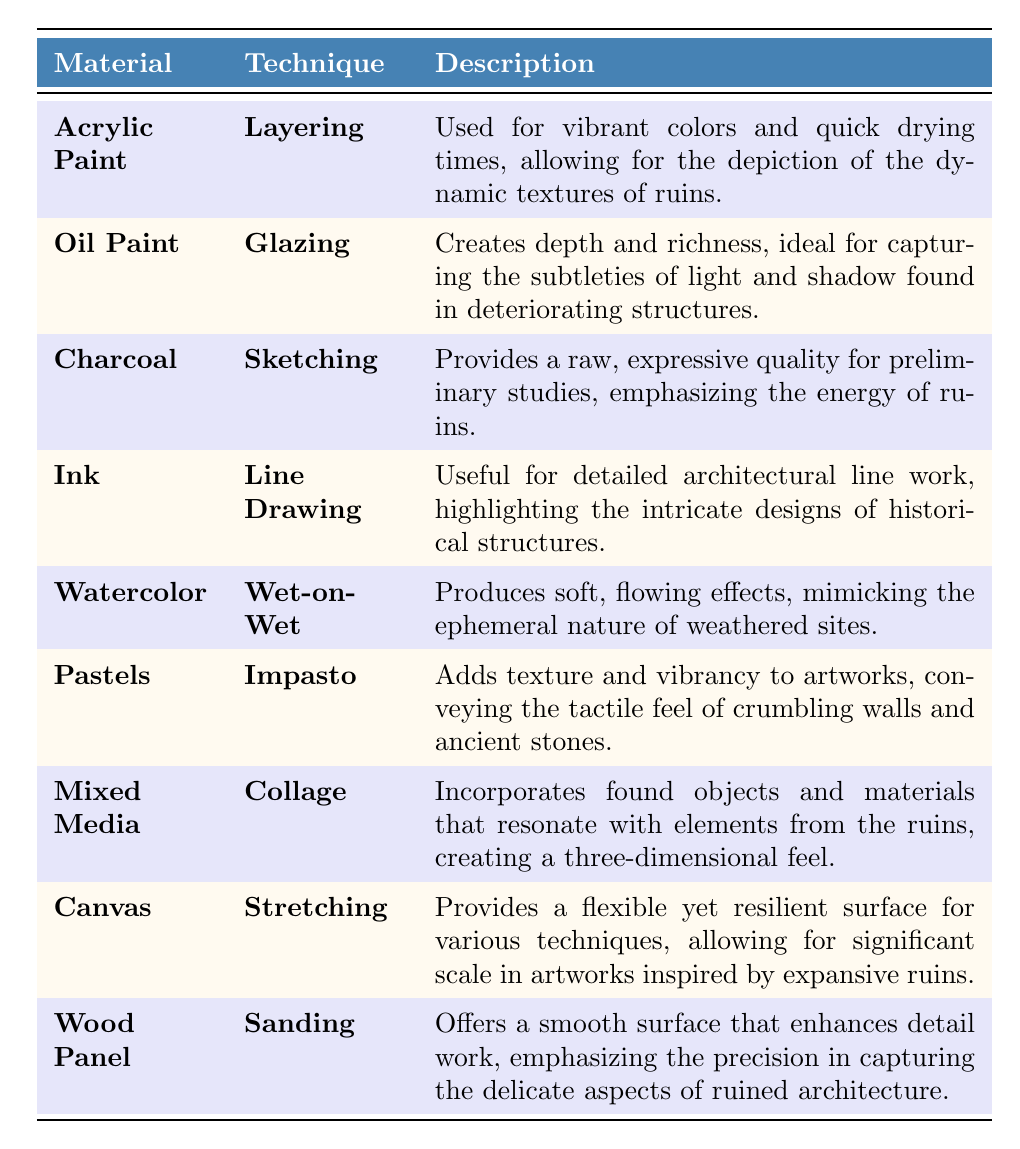What material is used for the technique of layering? According to the table, acrylic paint is used for the technique of layering.
Answer: Acrylic paint Which technique is used with oil paint? The table shows that the technique used with oil paint is glazing.
Answer: Glazing How many materials are listed in the table? There are 9 materials listed in the table.
Answer: 9 Is charcoal used for detailed line work? The table indicates that charcoal is used for sketching, not detailed line work; ink is the medium for that purpose.
Answer: No Which material is associated with creating depth and richness? The table states that oil paint is associated with creating depth and richness.
Answer: Oil paint What is the purpose of using mixed media in artwork? The table explains that mixed media incorporates found objects and materials that resonate with elements from the ruins, creating a three-dimensional feel.
Answer: To create a three-dimensional feel Which two techniques are specifically mentioned for producing suitable effects related to ruins? The table mentions layering with acrylic paint and wet-on-wet with watercolor as techniques that produce effects related to ruins.
Answer: Layering and wet-on-wet What material has the technique "collage"? According to the table, mixed media has the technique "collage."
Answer: Mixed media If you were to rank materials for texture based on the table, which two materials would likely rank highest considering impasto and collage techniques? Based on the descriptions, pastels (impasto) and mixed media (collage) would rank highest for texture, as both are designed to add texture to artwork.
Answer: Pastels and mixed media Which materials suggest a focus on intricate details and precision in artwork? The table specifies that ink (line drawing) and wood panel (sanding) suggest a focus on intricate details and precision in artwork.
Answer: Ink and wood panel What is the common theme among the techniques used for watercolor and pastel mediums? Both watercolor and pastel techniques aim to create effects that enhance the representation of ruins, focusing on soft (watercolor) and textured (pastel) qualities.
Answer: Creating effects that enhance representation of ruins 